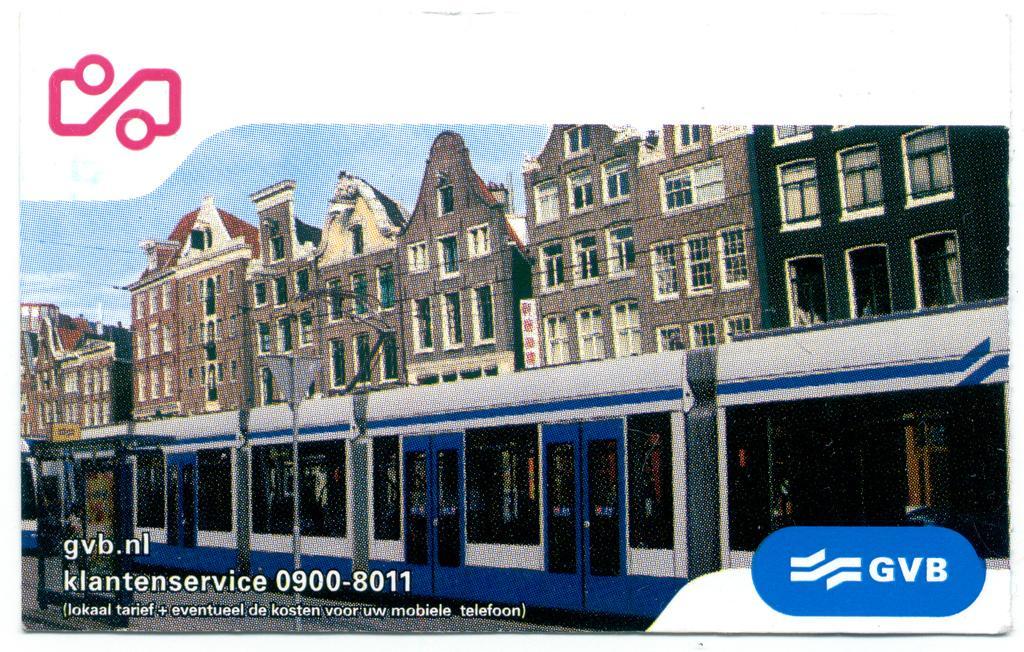In one or two sentences, can you explain what this image depicts? In this image I can see an edited image and I can see the building ,train,pole and the sky. 